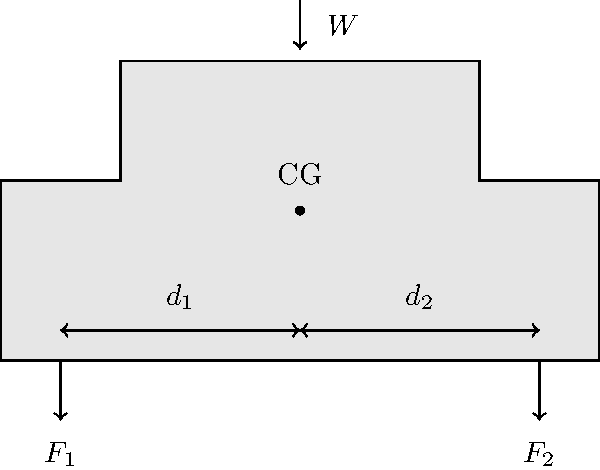A commercial truck has two axles as shown in the diagram. The total weight of the truck and its load is $W = 30,000 \text{ N}$, with the center of gravity (CG) located at distances $d_1 = 3 \text{ m}$ and $d_2 = 2 \text{ m}$ from the front and rear axles, respectively. Calculate the force $F_2$ on the rear axle. To solve this problem, we'll use the principle of moments and the equilibrium condition. Here's a step-by-step approach:

1) First, we need to understand that the sum of forces on both axles must equal the total weight of the truck:

   $F_1 + F_2 = W$

2) Next, we can use the principle of moments. The moment around any point should be zero for the truck to be in equilibrium. Let's take moments around the front axle:

   $F_2 \cdot (d_1 + d_2) - W \cdot d_1 = 0$

3) We can rearrange this equation to solve for $F_2$:

   $F_2 = \frac{W \cdot d_1}{d_1 + d_2}$

4) Now, let's substitute the given values:
   $W = 30,000 \text{ N}$
   $d_1 = 3 \text{ m}$
   $d_2 = 2 \text{ m}$

   $F_2 = \frac{30,000 \text{ N} \cdot 3 \text{ m}}{3 \text{ m} + 2 \text{ m}} = \frac{90,000 \text{ N}\cdot\text{m}}{5 \text{ m}}$

5) Simplify:

   $F_2 = 18,000 \text{ N}$

Therefore, the force on the rear axle is 18,000 N.
Answer: $18,000 \text{ N}$ 